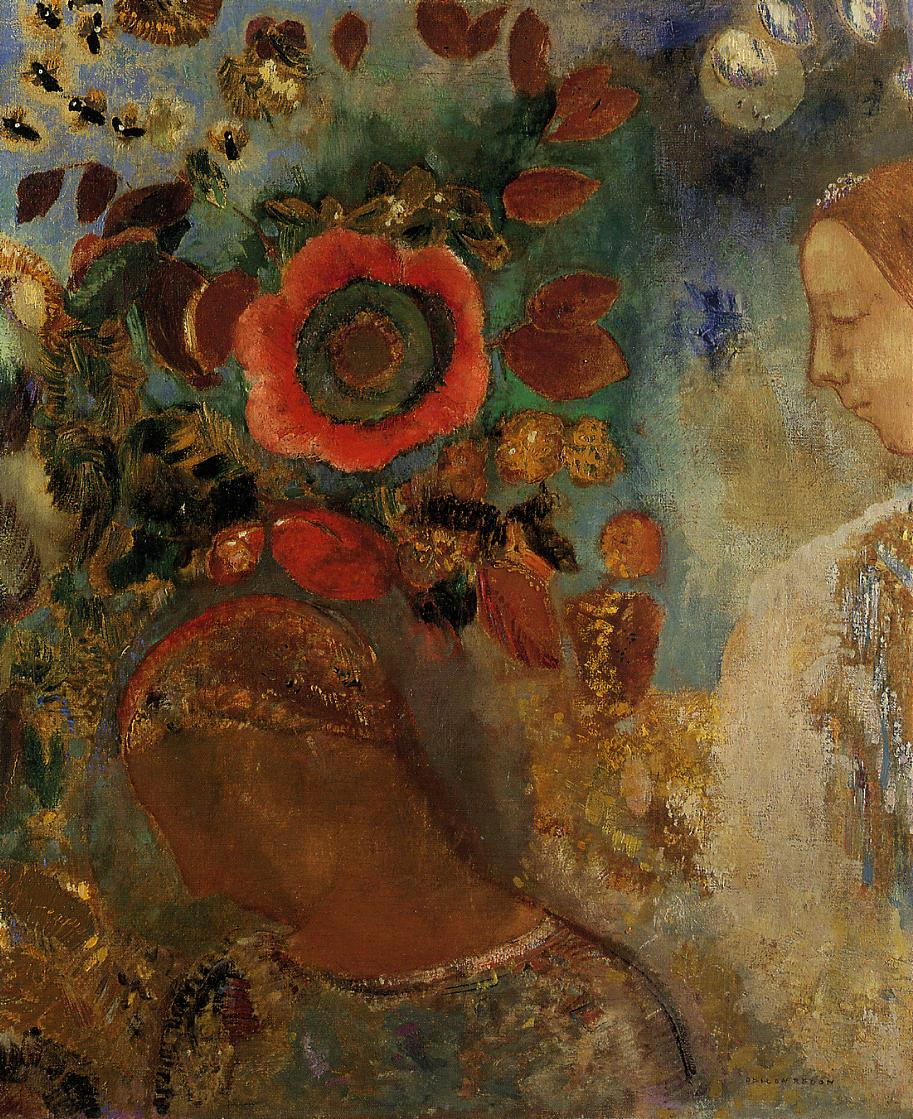How does the artist use color to convey the mood of the painting? The artist masterfully utilizes a palette that combines warm reds and golds with cooler blues and greens to create a balanced yet dynamic visual experience. The warm colors of the flower and the foliage surrounding the woman give the scene a lively, energetic feel, while the cooler tones in the background bring a calming, tranquil quality. This juxtaposition of color temperature effectively conveys a mood that is both introspective and vibrant, mirroring the complexity of human emotions and the contemplative nature of the subject. 